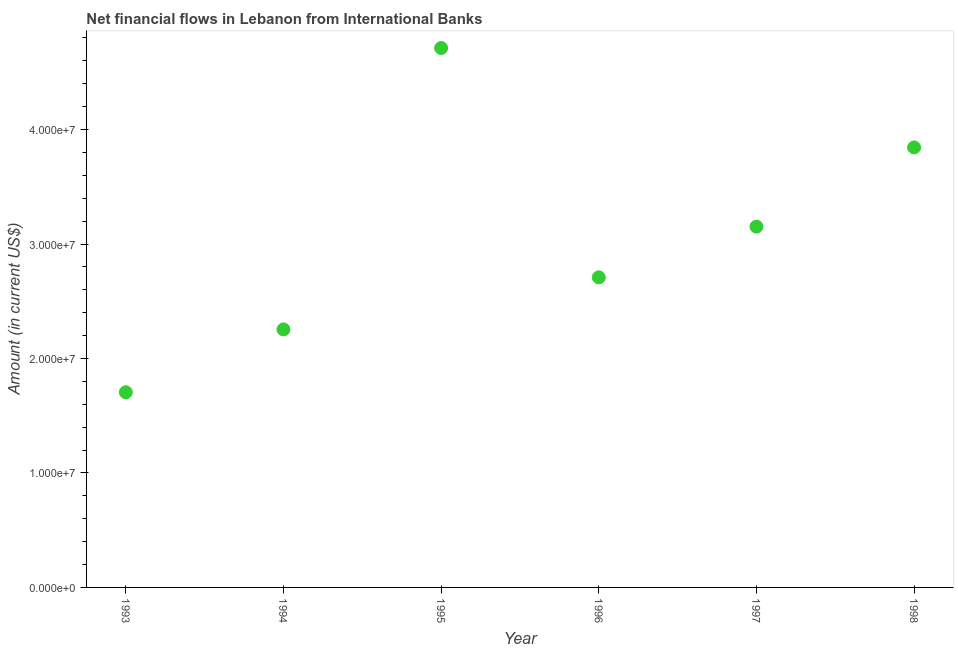What is the net financial flows from ibrd in 1997?
Provide a short and direct response. 3.15e+07. Across all years, what is the maximum net financial flows from ibrd?
Offer a very short reply. 4.71e+07. Across all years, what is the minimum net financial flows from ibrd?
Your answer should be compact. 1.70e+07. In which year was the net financial flows from ibrd minimum?
Your response must be concise. 1993. What is the sum of the net financial flows from ibrd?
Keep it short and to the point. 1.84e+08. What is the difference between the net financial flows from ibrd in 1995 and 1997?
Make the answer very short. 1.56e+07. What is the average net financial flows from ibrd per year?
Give a very brief answer. 3.06e+07. What is the median net financial flows from ibrd?
Provide a short and direct response. 2.93e+07. What is the ratio of the net financial flows from ibrd in 1993 to that in 1997?
Offer a terse response. 0.54. What is the difference between the highest and the second highest net financial flows from ibrd?
Make the answer very short. 8.68e+06. What is the difference between the highest and the lowest net financial flows from ibrd?
Your response must be concise. 3.01e+07. How many dotlines are there?
Ensure brevity in your answer.  1. How many years are there in the graph?
Ensure brevity in your answer.  6. What is the difference between two consecutive major ticks on the Y-axis?
Ensure brevity in your answer.  1.00e+07. Does the graph contain any zero values?
Provide a short and direct response. No. What is the title of the graph?
Keep it short and to the point. Net financial flows in Lebanon from International Banks. What is the label or title of the Y-axis?
Ensure brevity in your answer.  Amount (in current US$). What is the Amount (in current US$) in 1993?
Offer a terse response. 1.70e+07. What is the Amount (in current US$) in 1994?
Offer a terse response. 2.25e+07. What is the Amount (in current US$) in 1995?
Offer a very short reply. 4.71e+07. What is the Amount (in current US$) in 1996?
Offer a terse response. 2.71e+07. What is the Amount (in current US$) in 1997?
Ensure brevity in your answer.  3.15e+07. What is the Amount (in current US$) in 1998?
Your answer should be compact. 3.84e+07. What is the difference between the Amount (in current US$) in 1993 and 1994?
Ensure brevity in your answer.  -5.49e+06. What is the difference between the Amount (in current US$) in 1993 and 1995?
Provide a succinct answer. -3.01e+07. What is the difference between the Amount (in current US$) in 1993 and 1996?
Offer a very short reply. -1.00e+07. What is the difference between the Amount (in current US$) in 1993 and 1997?
Provide a succinct answer. -1.45e+07. What is the difference between the Amount (in current US$) in 1993 and 1998?
Your answer should be very brief. -2.14e+07. What is the difference between the Amount (in current US$) in 1994 and 1995?
Keep it short and to the point. -2.46e+07. What is the difference between the Amount (in current US$) in 1994 and 1996?
Offer a very short reply. -4.54e+06. What is the difference between the Amount (in current US$) in 1994 and 1997?
Offer a very short reply. -8.98e+06. What is the difference between the Amount (in current US$) in 1994 and 1998?
Make the answer very short. -1.59e+07. What is the difference between the Amount (in current US$) in 1995 and 1996?
Ensure brevity in your answer.  2.00e+07. What is the difference between the Amount (in current US$) in 1995 and 1997?
Your answer should be compact. 1.56e+07. What is the difference between the Amount (in current US$) in 1995 and 1998?
Make the answer very short. 8.68e+06. What is the difference between the Amount (in current US$) in 1996 and 1997?
Give a very brief answer. -4.43e+06. What is the difference between the Amount (in current US$) in 1996 and 1998?
Your answer should be compact. -1.14e+07. What is the difference between the Amount (in current US$) in 1997 and 1998?
Offer a terse response. -6.92e+06. What is the ratio of the Amount (in current US$) in 1993 to that in 1994?
Offer a terse response. 0.76. What is the ratio of the Amount (in current US$) in 1993 to that in 1995?
Provide a short and direct response. 0.36. What is the ratio of the Amount (in current US$) in 1993 to that in 1996?
Your answer should be compact. 0.63. What is the ratio of the Amount (in current US$) in 1993 to that in 1997?
Provide a short and direct response. 0.54. What is the ratio of the Amount (in current US$) in 1993 to that in 1998?
Provide a succinct answer. 0.44. What is the ratio of the Amount (in current US$) in 1994 to that in 1995?
Offer a terse response. 0.48. What is the ratio of the Amount (in current US$) in 1994 to that in 1996?
Provide a short and direct response. 0.83. What is the ratio of the Amount (in current US$) in 1994 to that in 1997?
Provide a succinct answer. 0.71. What is the ratio of the Amount (in current US$) in 1994 to that in 1998?
Ensure brevity in your answer.  0.59. What is the ratio of the Amount (in current US$) in 1995 to that in 1996?
Provide a succinct answer. 1.74. What is the ratio of the Amount (in current US$) in 1995 to that in 1997?
Your answer should be very brief. 1.5. What is the ratio of the Amount (in current US$) in 1995 to that in 1998?
Your answer should be very brief. 1.23. What is the ratio of the Amount (in current US$) in 1996 to that in 1997?
Give a very brief answer. 0.86. What is the ratio of the Amount (in current US$) in 1996 to that in 1998?
Provide a succinct answer. 0.7. What is the ratio of the Amount (in current US$) in 1997 to that in 1998?
Give a very brief answer. 0.82. 